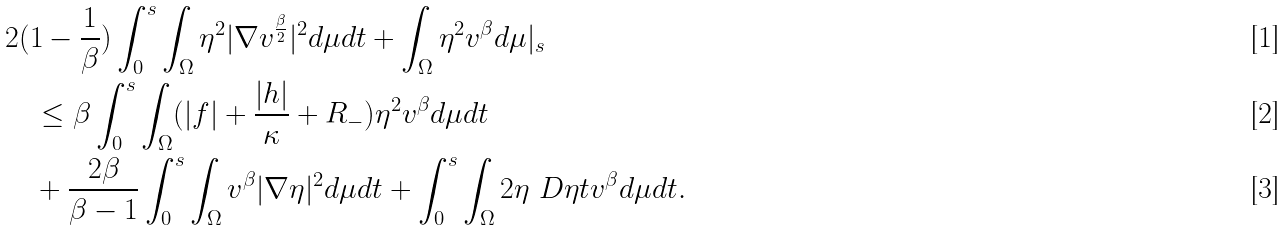Convert formula to latex. <formula><loc_0><loc_0><loc_500><loc_500>& 2 ( 1 - \frac { 1 } { \beta } ) \int _ { 0 } ^ { s } \int _ { \Omega } \eta ^ { 2 } | \nabla v ^ { \frac { \beta } { 2 } } | ^ { 2 } d \mu d t + \int _ { \Omega } \eta ^ { 2 } v ^ { \beta } d \mu | _ { s } \\ & \quad \leq \beta \int _ { 0 } ^ { s } \int _ { \Omega } ( | f | + \frac { | h | } { \kappa } + R _ { - } ) \eta ^ { 2 } v ^ { \beta } d \mu d t \\ & \quad + \frac { 2 \beta } { \beta - 1 } \int _ { 0 } ^ { s } \int _ { \Omega } v ^ { \beta } | \nabla \eta | ^ { 2 } d \mu d t + \int _ { 0 } ^ { s } \int _ { \Omega } 2 \eta \ D { \eta } { t } v ^ { \beta } d \mu d t .</formula> 